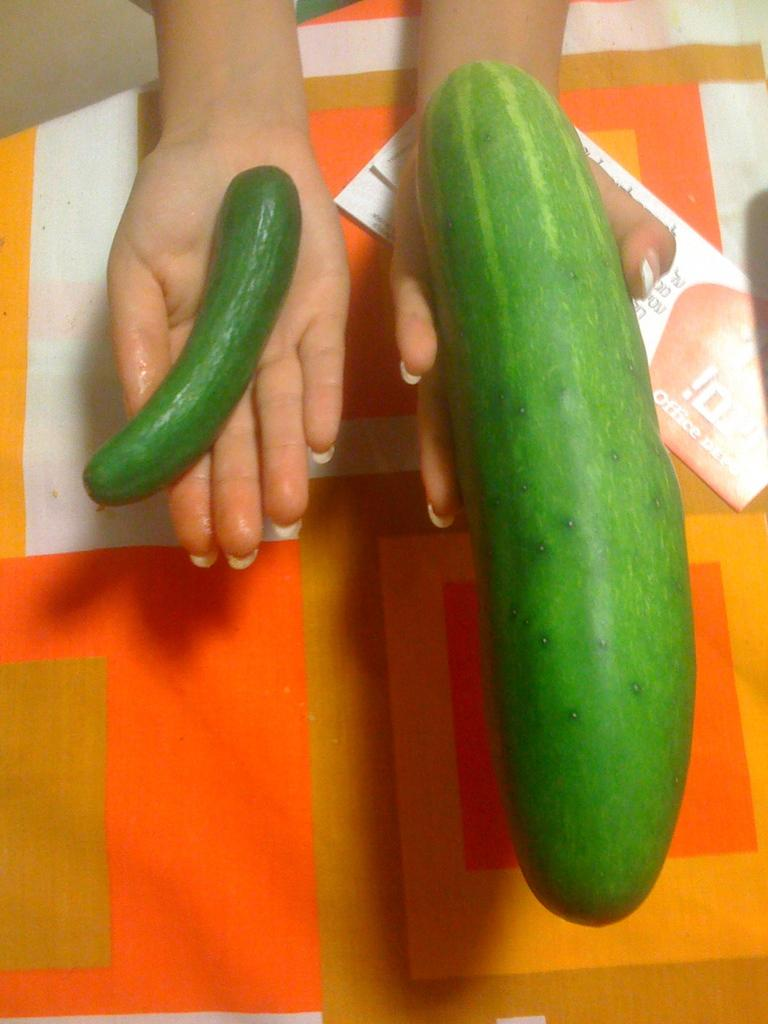What type of vegetable can be seen in the image? There are two cucumbers in the image. Who is holding the cucumbers in the image? A human is holding the cucumbers. What can be seen in the background of the image? There is a paper visible in the background of the image. What type of string is being used to detail the quilt in the image? There is no string or quilt present in the image; it features two cucumbers being held by a human. 